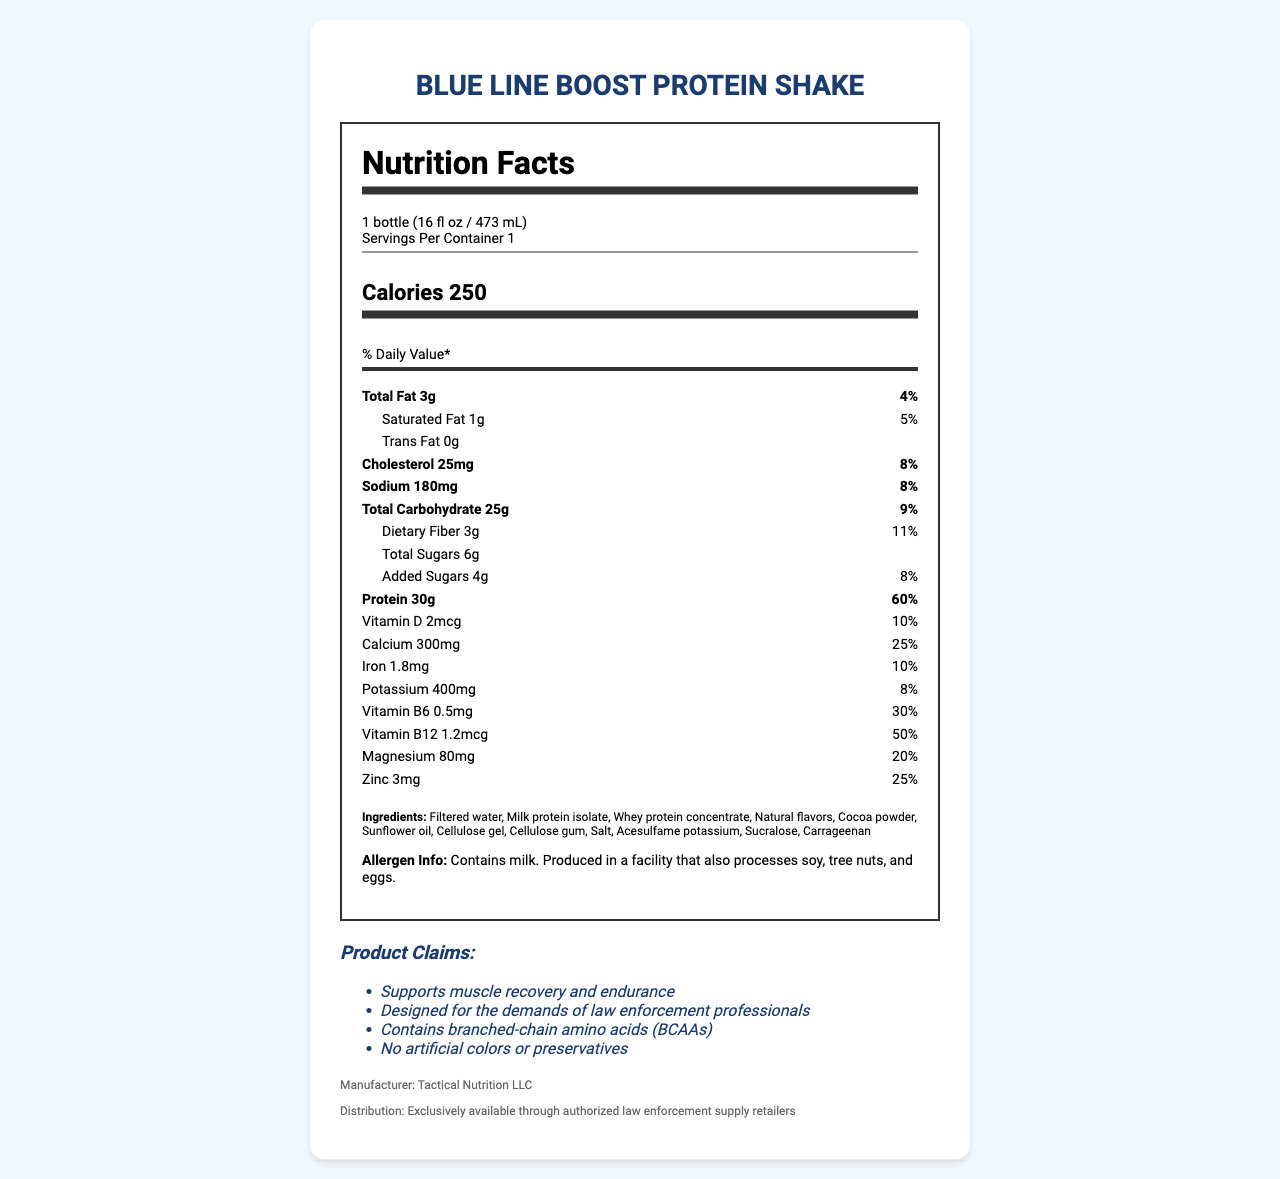how many grams of protein are there per serving? The document specifies that each serving of the Blue Line Boost Protein Shake contains 30 grams of protein.
Answer: 30 grams what is the serving size of the Blue Line Boost Protein Shake? The serving size is explicitly stated in the document as 1 bottle, which is equivalent to 16 fl oz or 473 mL.
Answer: 1 bottle (16 fl oz / 473 mL) how many calories are in one serving of the protein shake? The document lists the calorie content as 250 calories per serving.
Answer: 250 calories how much calcium does one serving provide as a percentage of the daily value? The calcium content per serving is 300mg, which is 25% of the daily value as indicated in the document.
Answer: 25% what allergens are present in the Blue Line Boost Protein Shake? The allergen information mentions that the shake contains milk and is produced in a facility that also processes soy, tree nuts, and eggs.
Answer: Contains milk. Produced in a facility that also processes soy, tree nuts, and eggs. what are the first three ingredients listed for the protein shake? The first three ingredients listed in the document are Filtered water, Milk protein isolate, and Whey protein concentrate.
Answer: Filtered water, Milk protein isolate, Whey protein concentrate how many grams of total carbohydrate are there per serving? The document specifies that each serving contains 25 grams of total carbohydrate.
Answer: 25 grams how does the protein content compare to the daily value percentage-wise? The protein content per serving is 30 grams, which is 60% of the daily value.
Answer: 60% which ingredient is used as a sweetener in the Blue Line Boost Protein Shake? A. Acesulfame potassium B. Sucralose C. Sugar The ingredients list includes Sucralose, which is known as an artificial sweetener.
Answer: B. Sucralose what is the purpose of the product, particularly for law enforcement professionals? A. Weight loss B. Muscle recovery and endurance C. Increased appetite One of the product claims is that it supports muscle recovery and endurance, specifically designed for the demands of law enforcement professionals.
Answer: B. Muscle recovery and endurance does the product contain any iron? The document lists iron as one of the nutrients and provides 1.8mg per serving, which is 10% of the daily value.
Answer: Yes is the Blue Line Boost Protein Shake marketed towards the general public? The distribution information states that the product is exclusively available through authorized law enforcement supply retailers, indicating it is targeted specifically towards law enforcement professionals.
Answer: No summarize the main claims and nutritional highlights of the Blue Line Boost Protein Shake. The document lists several product claims, including its design for law enforcement professionals and its muscle recovery benefits. The nutritional facts underscore high protein content and a good range of vitamins and minerals. There are also specific details about the ingredients and absence of artificial colors or preservatives, and allergen information.
Answer: The Blue Line Boost Protein Shake is designed specifically for law enforcement officers to support muscle recovery and endurance. It contains a significant amount of protein (30g or 60% DV), moderate amounts of fat (3g, 4% DV) and carbohydrates (25g, 9% DV), and is enriched with various vitamins and minerals like calcium (25% DV), vitamin B6 (30% DV), and vitamin B12 (50% DV). Additionally, it contains no artificial colors or preservatives and is produced in a facility that processes soy, tree nuts, and eggs. how much potassium does one serving have in milligrams? The potassium content for one serving is specified as 400mg in the document.
Answer: 400mg which vitamin has the highest daily value percentage in the shake? Vitamin B12 has a daily value percentage of 50%, which is the highest among the listed vitamins and minerals in the document.
Answer: Vitamin B12 how many grams of dietary fiber does the protein shake contain? The document states that each serving contains 3 grams of dietary fiber, which is 11% of the daily value.
Answer: 3 grams why is the product branded as "Blue Line Boost"? The document does not provide information on the branding rationale behind the name "Blue Line Boost."
Answer: Cannot be determined what is the daily value percentage for sodium in one serving? The document indicates that the sodium content per serving is 180mg, which is 8% of the daily value.
Answer: 8% 